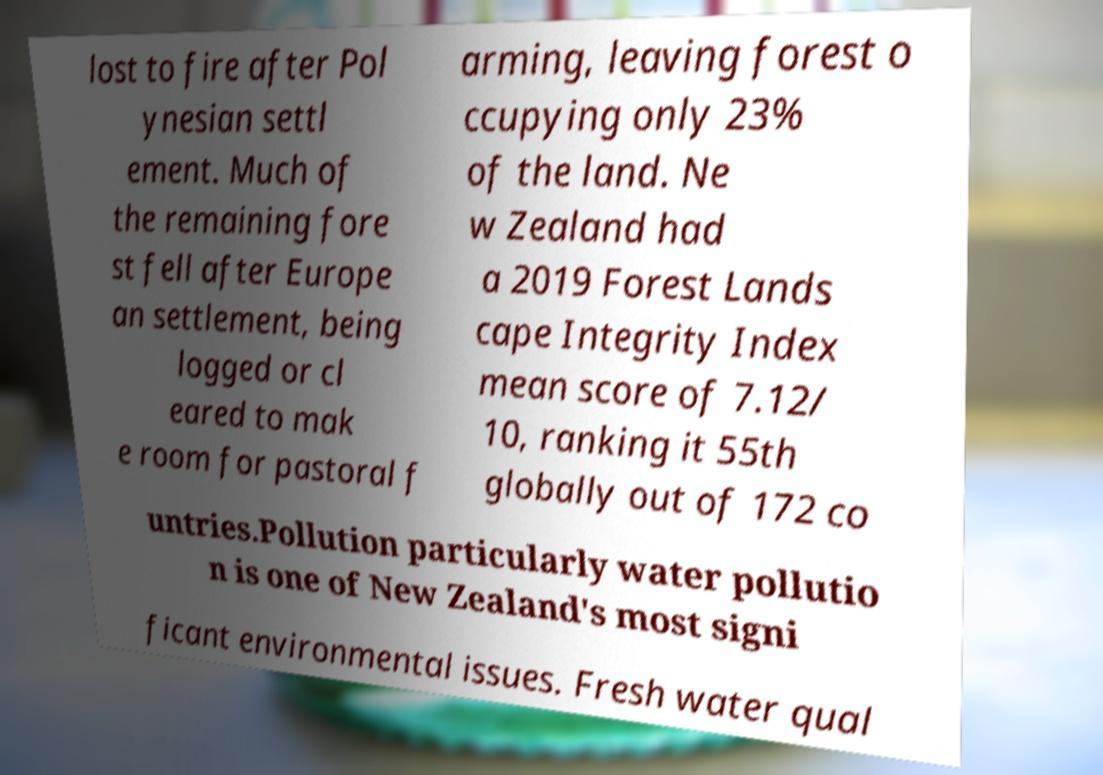I need the written content from this picture converted into text. Can you do that? lost to fire after Pol ynesian settl ement. Much of the remaining fore st fell after Europe an settlement, being logged or cl eared to mak e room for pastoral f arming, leaving forest o ccupying only 23% of the land. Ne w Zealand had a 2019 Forest Lands cape Integrity Index mean score of 7.12/ 10, ranking it 55th globally out of 172 co untries.Pollution particularly water pollutio n is one of New Zealand's most signi ficant environmental issues. Fresh water qual 